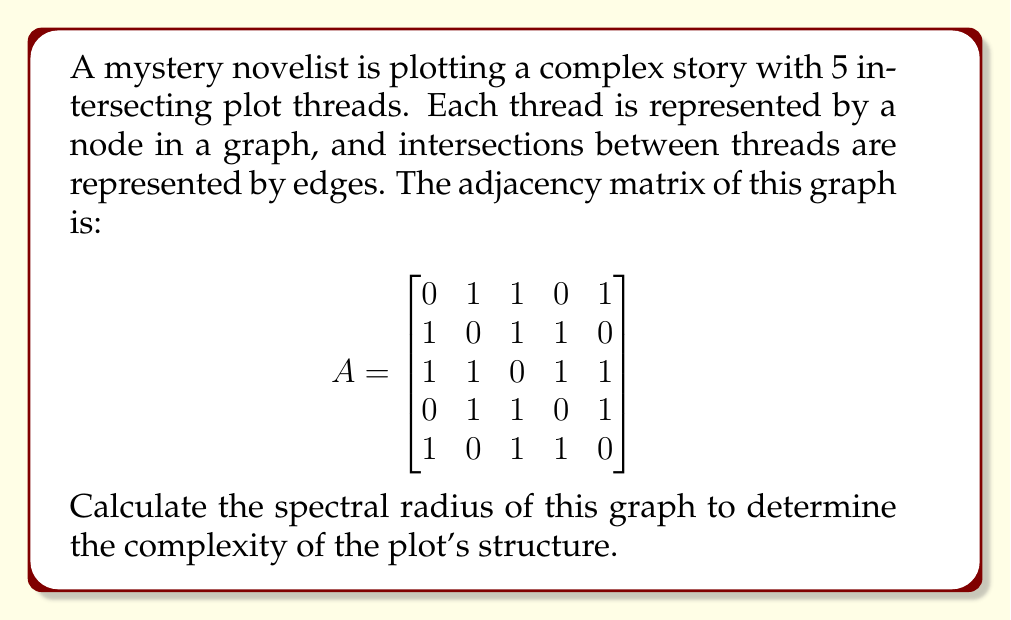Can you solve this math problem? To find the spectral radius of the graph, we need to follow these steps:

1) The spectral radius is the largest absolute eigenvalue of the adjacency matrix A.

2) To find the eigenvalues, we need to solve the characteristic equation:
   $$\det(A - \lambda I) = 0$$

3) Expanding this determinant:
   $$\begin{vmatrix}
   -\lambda & 1 & 1 & 0 & 1 \\
   1 & -\lambda & 1 & 1 & 0 \\
   1 & 1 & -\lambda & 1 & 1 \\
   0 & 1 & 1 & -\lambda & 1 \\
   1 & 0 & 1 & 1 & -\lambda
   \end{vmatrix} = 0$$

4) This expands to the characteristic polynomial:
   $$\lambda^5 - 10\lambda^3 - 5\lambda^2 + 4\lambda + 1 = 0$$

5) This polynomial is difficult to solve analytically, so we use numerical methods.

6) Using a numerical solver, we find the roots of this polynomial:
   $\lambda_1 \approx 2.7735$
   $\lambda_2 \approx -1.7735$
   $\lambda_3 \approx 0.7735$
   $\lambda_4 \approx -0.7735$
   $\lambda_5 = 0$

7) The spectral radius is the largest absolute value among these eigenvalues.

8) Therefore, the spectral radius is approximately 2.7735.
Answer: $2.7735$ (rounded to 4 decimal places) 